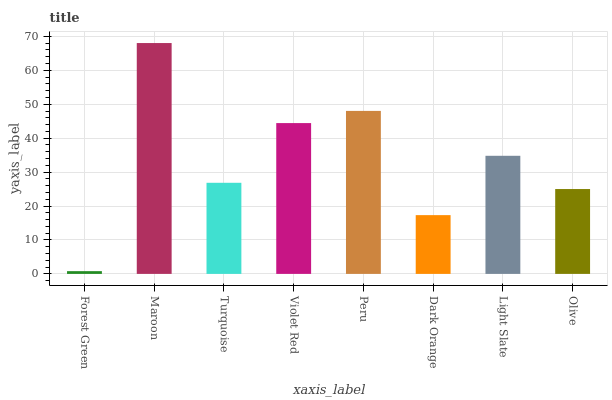Is Forest Green the minimum?
Answer yes or no. Yes. Is Maroon the maximum?
Answer yes or no. Yes. Is Turquoise the minimum?
Answer yes or no. No. Is Turquoise the maximum?
Answer yes or no. No. Is Maroon greater than Turquoise?
Answer yes or no. Yes. Is Turquoise less than Maroon?
Answer yes or no. Yes. Is Turquoise greater than Maroon?
Answer yes or no. No. Is Maroon less than Turquoise?
Answer yes or no. No. Is Light Slate the high median?
Answer yes or no. Yes. Is Turquoise the low median?
Answer yes or no. Yes. Is Maroon the high median?
Answer yes or no. No. Is Maroon the low median?
Answer yes or no. No. 